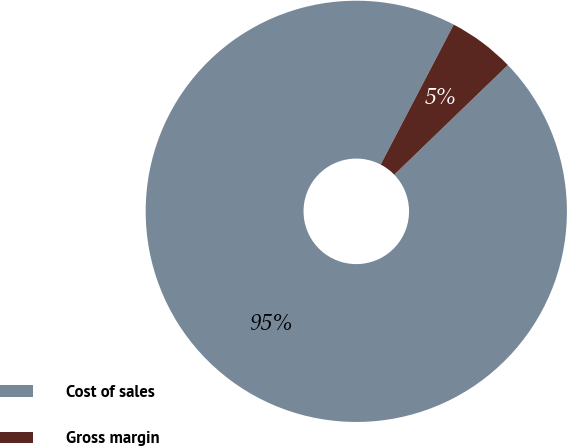Convert chart. <chart><loc_0><loc_0><loc_500><loc_500><pie_chart><fcel>Cost of sales<fcel>Gross margin<nl><fcel>94.87%<fcel>5.13%<nl></chart> 